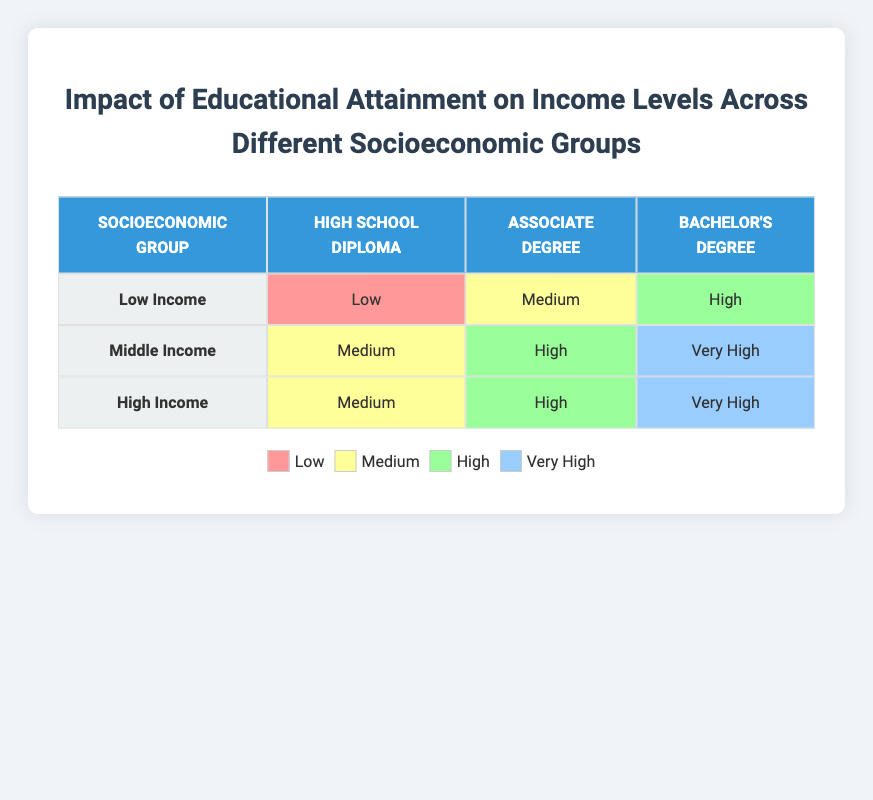What is the income level associated with a Bachelor's Degree in the Low Income group? The Low Income group has the income level of High associated with a Bachelor's Degree based on the table provided.
Answer: High Are there any socioeconomic groups that have a High income level with only a High School Diploma? In the table, no socioeconomic group has a High income level associated with only a High School Diploma. The Low Income group has Low, Middle Income has Medium, and High Income has Medium as well.
Answer: No What is the income level for the Middle Income group with an Associate Degree? The income level for the Middle Income group with an Associate Degree, according to the table, is High.
Answer: High Which socioeconomic group shows an increase in income level as educational attainment increases from High School Diploma to Bachelor's Degree? The Middle Income group shows an increase in income level from Medium with a High School Diploma to Very High with a Bachelor's Degree, illustrating an upward trend in income based on educational attainment.
Answer: Middle Income If we consider all groups, what percentage of the educational attainment levels correspond to Very High income? There are 2 instances of Very High income level across 9 entries in total. 2 out of 9 represents approximately 22.22%. Thus, the percentage of educational attainment levels that correspond to Very High income is about 22.22%.
Answer: 22.22% 